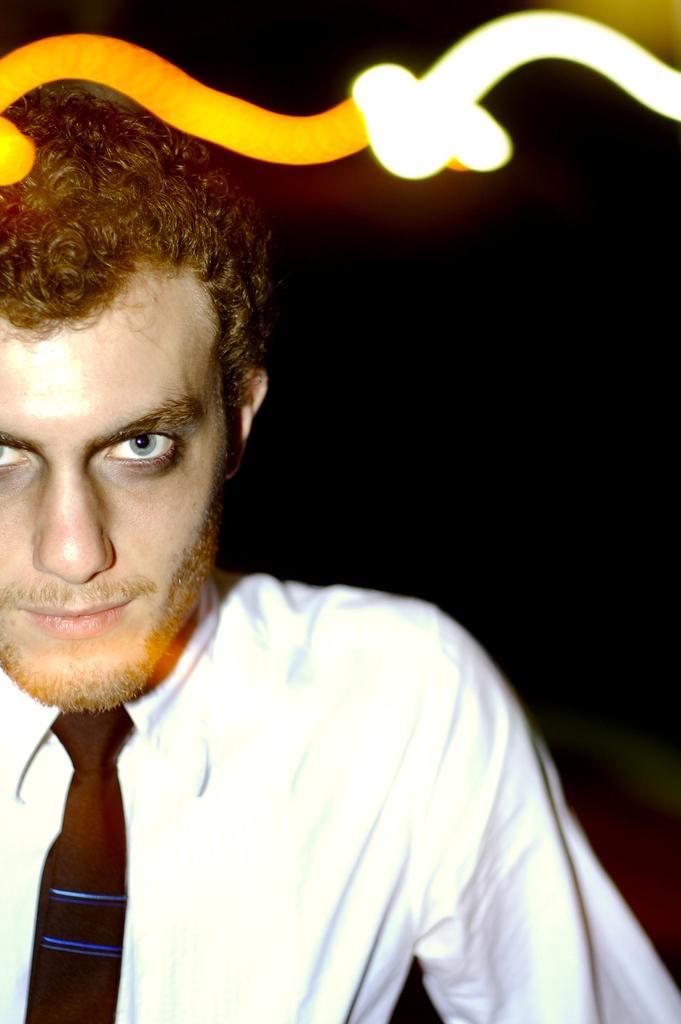In one or two sentences, can you explain what this image depicts? In this picture there is a man wearing white shirt and black tie is looking into the camera. Behind there is a dark background. 